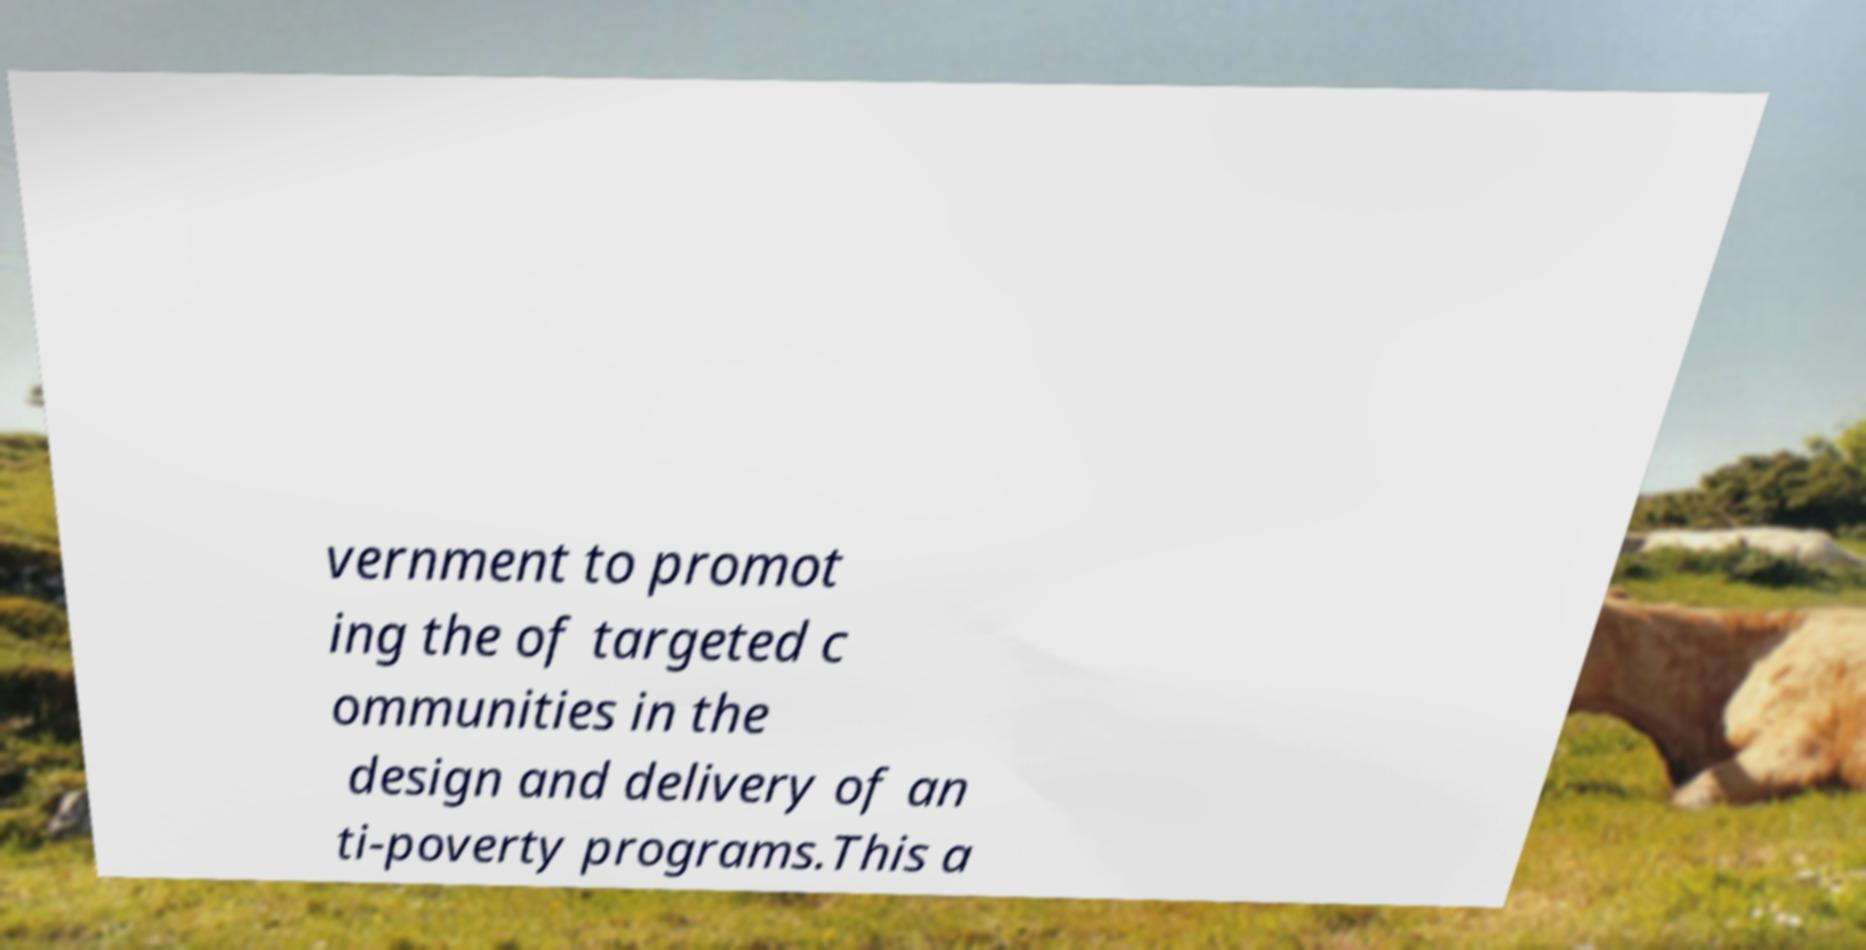Can you read and provide the text displayed in the image?This photo seems to have some interesting text. Can you extract and type it out for me? vernment to promot ing the of targeted c ommunities in the design and delivery of an ti-poverty programs.This a 